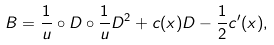Convert formula to latex. <formula><loc_0><loc_0><loc_500><loc_500>B = \frac { 1 } { u } \circ D \circ \frac { 1 } { u } D ^ { 2 } + c ( x ) D - \frac { 1 } { 2 } c ^ { \prime } ( x ) ,</formula> 